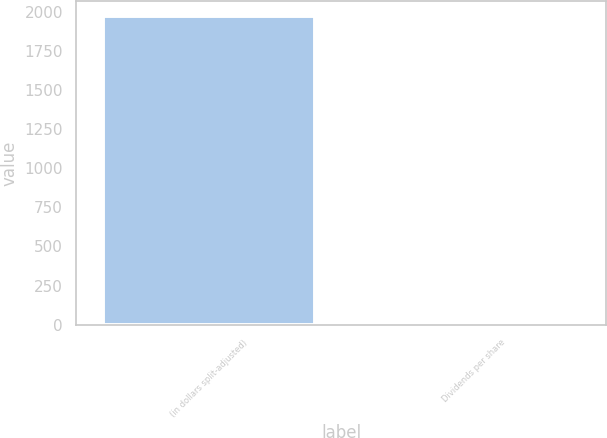Convert chart. <chart><loc_0><loc_0><loc_500><loc_500><bar_chart><fcel>(in dollars split-adjusted)<fcel>Dividends per share<nl><fcel>1969<fcel>0.04<nl></chart> 